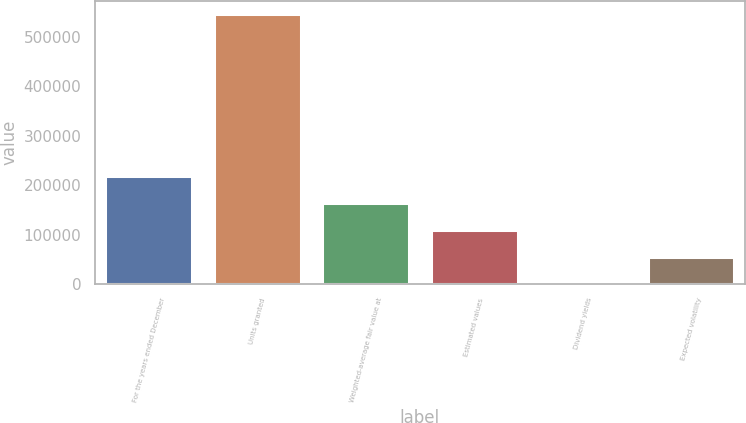Convert chart. <chart><loc_0><loc_0><loc_500><loc_500><bar_chart><fcel>For the years ended December<fcel>Units granted<fcel>Weighted-average fair value at<fcel>Estimated values<fcel>Dividend yields<fcel>Expected volatility<nl><fcel>218302<fcel>545750<fcel>163727<fcel>109152<fcel>2.5<fcel>54577.2<nl></chart> 